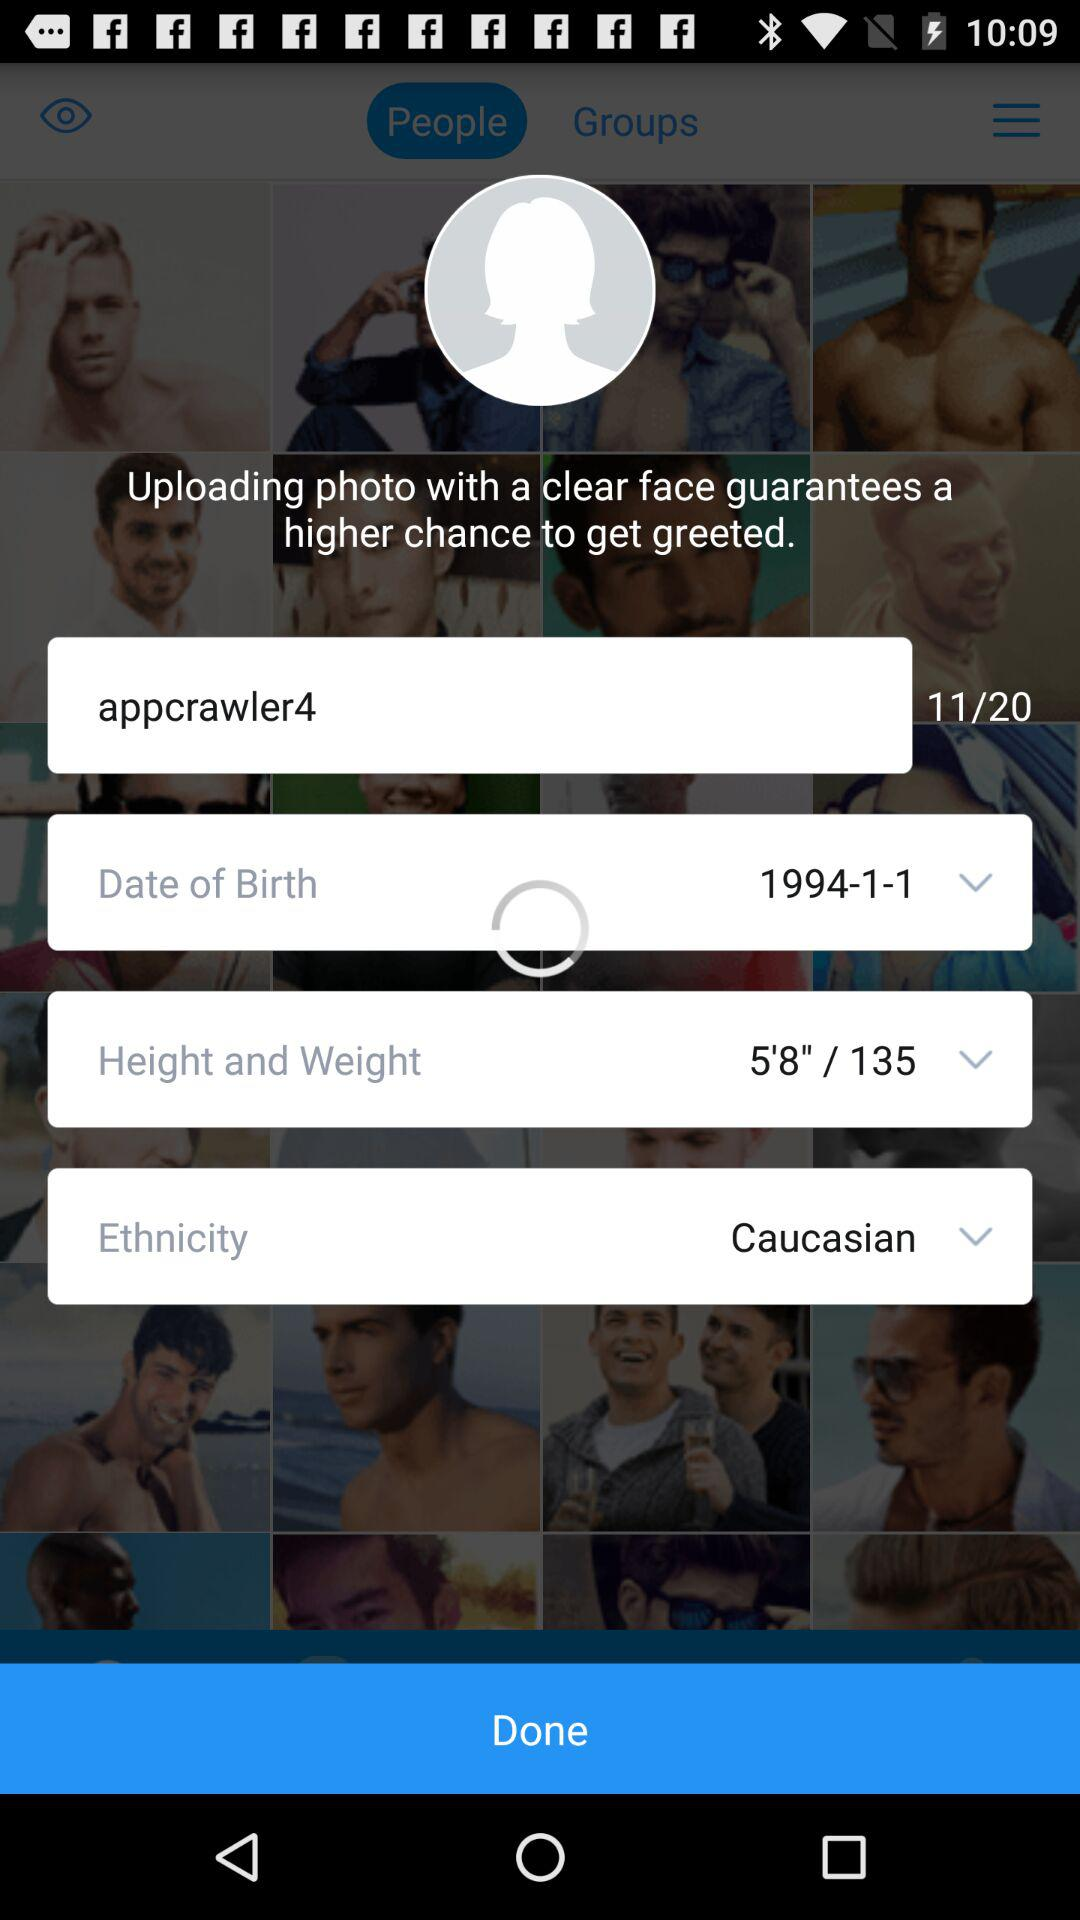What application will receive the public profile? The application that will receive the public profile is Blued. 